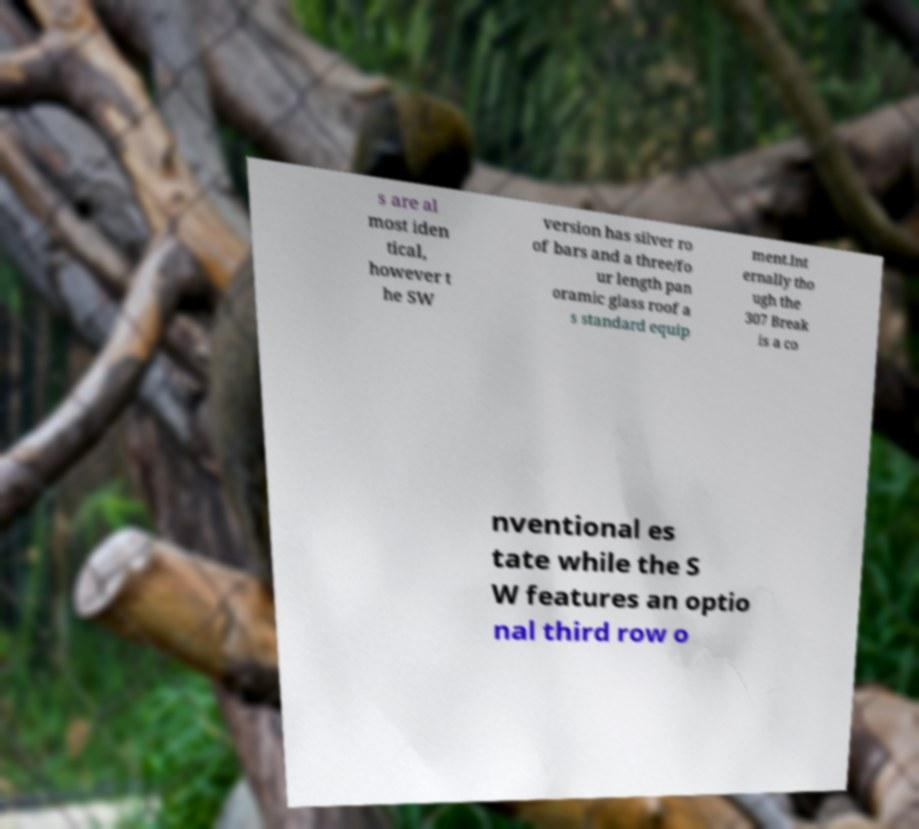Could you extract and type out the text from this image? s are al most iden tical, however t he SW version has silver ro of bars and a three/fo ur length pan oramic glass roof a s standard equip ment.Int ernally tho ugh the 307 Break is a co nventional es tate while the S W features an optio nal third row o 